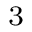<formula> <loc_0><loc_0><loc_500><loc_500>^ { 3 }</formula> 